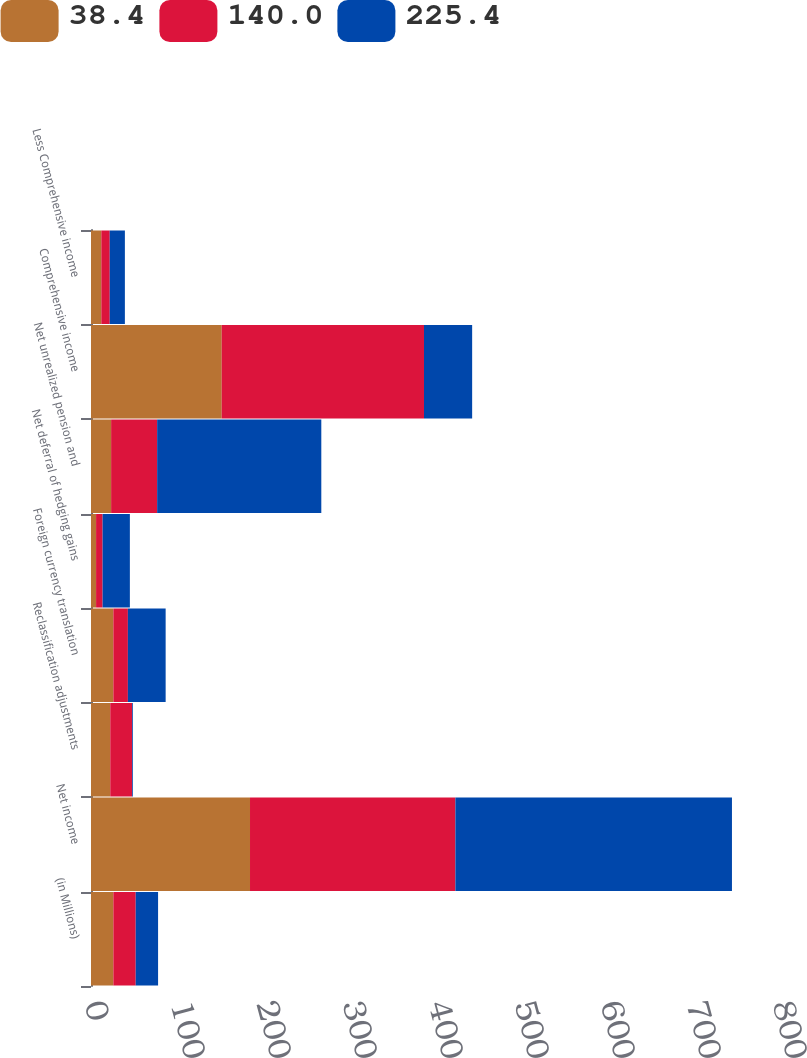Convert chart. <chart><loc_0><loc_0><loc_500><loc_500><stacked_bar_chart><ecel><fcel>(in Millions)<fcel>Net income<fcel>Reclassification adjustments<fcel>Foreign currency translation<fcel>Net deferral of hedging gains<fcel>Net unrealized pension and<fcel>Comprehensive income<fcel>Less Comprehensive income<nl><fcel>38.4<fcel>26<fcel>184.9<fcel>22.4<fcel>26<fcel>5.9<fcel>23.4<fcel>152<fcel>12<nl><fcel>140<fcel>26<fcel>238.8<fcel>25.4<fcel>16.9<fcel>7.6<fcel>53.5<fcel>235.2<fcel>9.8<nl><fcel>225.4<fcel>26<fcel>321.6<fcel>0.9<fcel>43.9<fcel>31.7<fcel>190.9<fcel>56<fcel>17.6<nl></chart> 